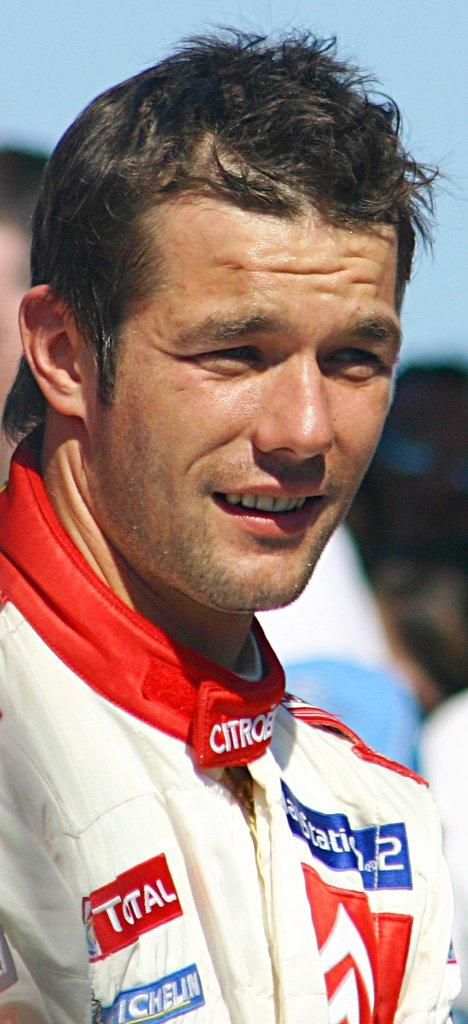<image>
Render a clear and concise summary of the photo. A man with a racing jacket that has patches on it one patch is michelin. 